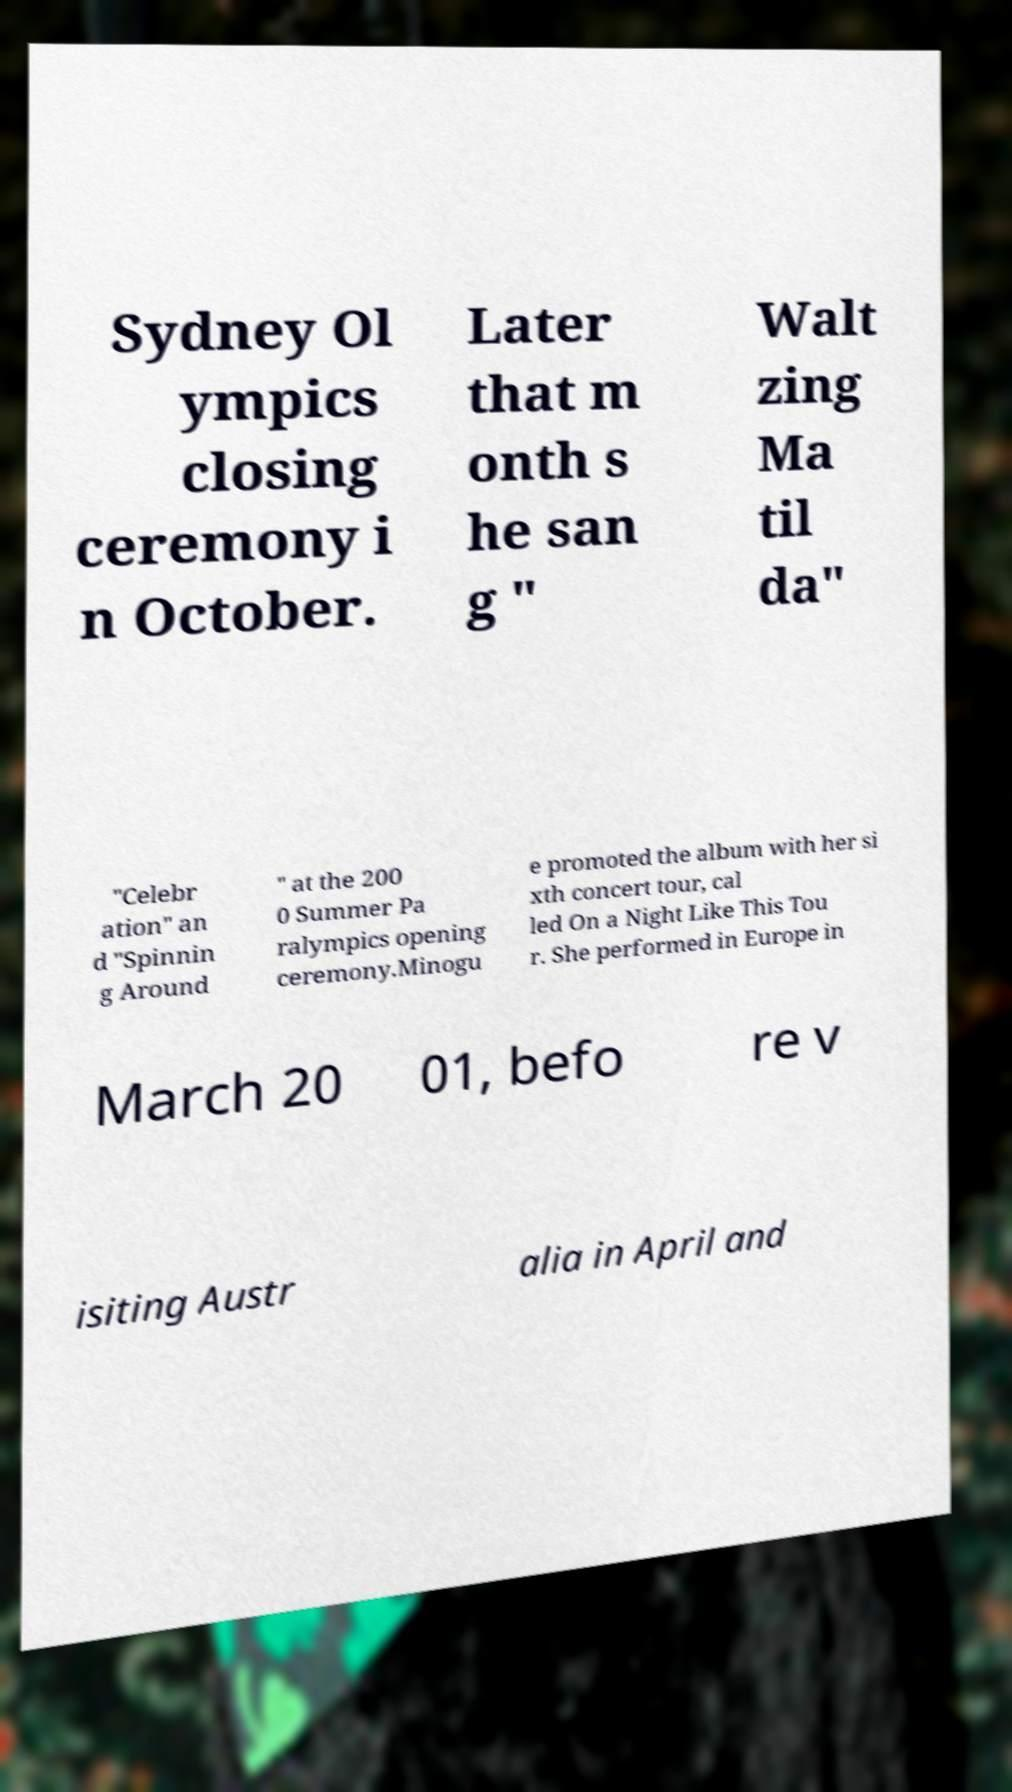Please read and relay the text visible in this image. What does it say? Sydney Ol ympics closing ceremony i n October. Later that m onth s he san g " Walt zing Ma til da" "Celebr ation" an d "Spinnin g Around " at the 200 0 Summer Pa ralympics opening ceremony.Minogu e promoted the album with her si xth concert tour, cal led On a Night Like This Tou r. She performed in Europe in March 20 01, befo re v isiting Austr alia in April and 